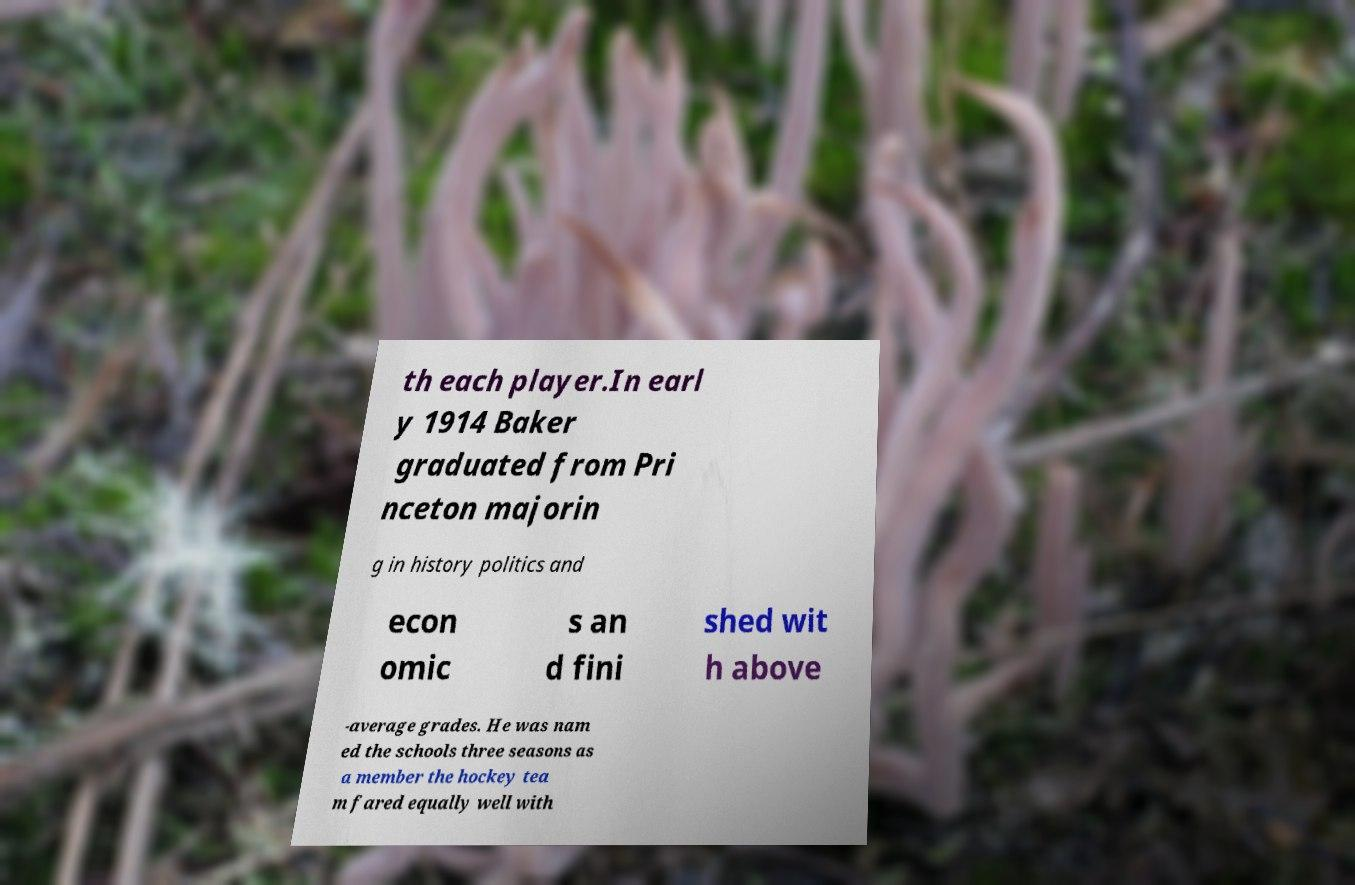Can you read and provide the text displayed in the image?This photo seems to have some interesting text. Can you extract and type it out for me? th each player.In earl y 1914 Baker graduated from Pri nceton majorin g in history politics and econ omic s an d fini shed wit h above -average grades. He was nam ed the schools three seasons as a member the hockey tea m fared equally well with 